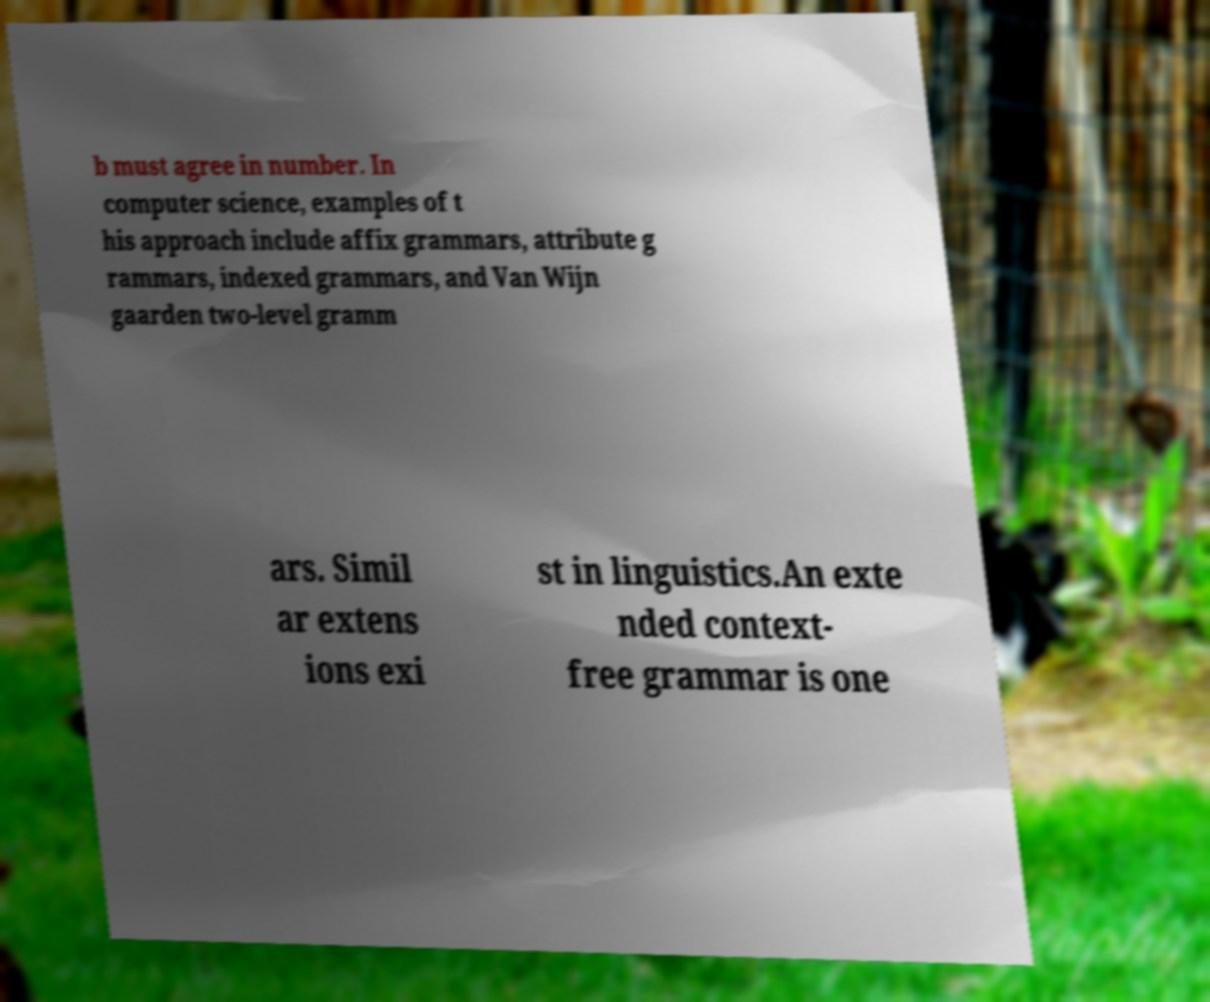Can you accurately transcribe the text from the provided image for me? b must agree in number. In computer science, examples of t his approach include affix grammars, attribute g rammars, indexed grammars, and Van Wijn gaarden two-level gramm ars. Simil ar extens ions exi st in linguistics.An exte nded context- free grammar is one 